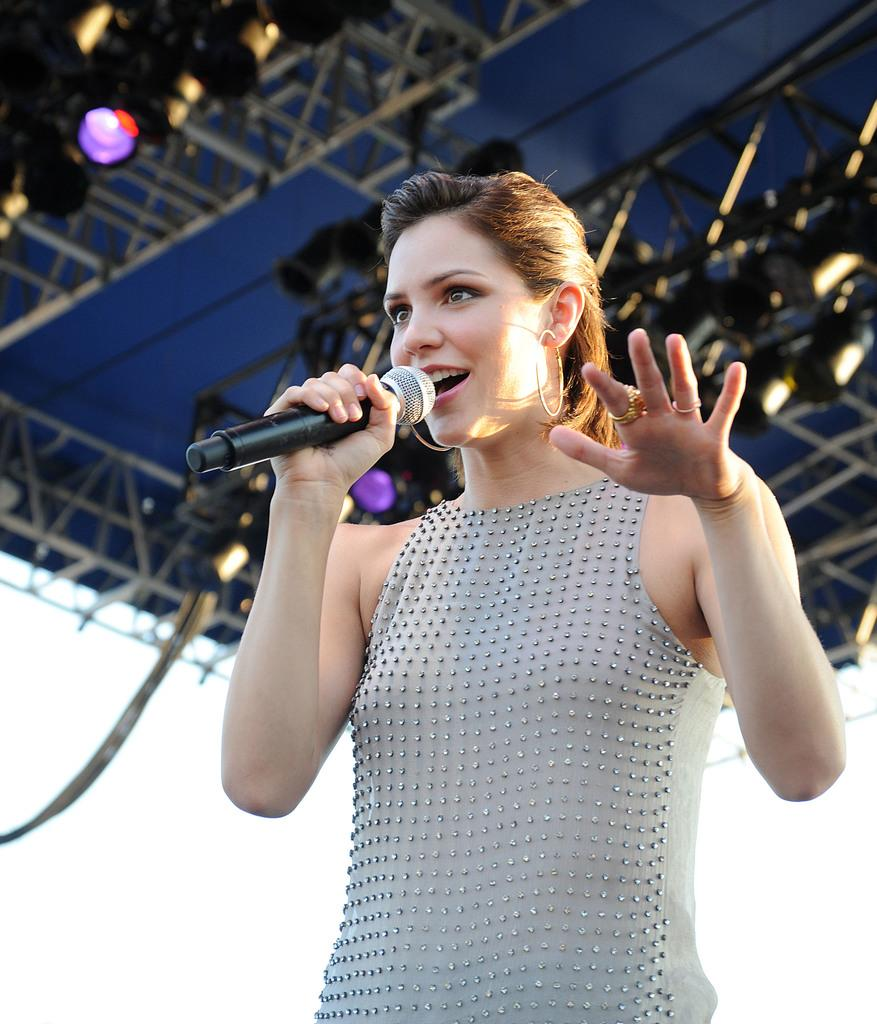Who is the main subject in the image? There is a woman in the image. What is the woman holding in the image? The woman is holding a mic. What is the woman wearing in the image? The woman is wearing a white dress. What can be seen in the background of the image? There is light visible in the background of the image. What type of pancake is the woman flipping in the image? There is no pancake present in the image; the woman is holding a mic. What kind of cap is the woman wearing in the image? The woman is not wearing a cap in the image; she is wearing a white dress. 